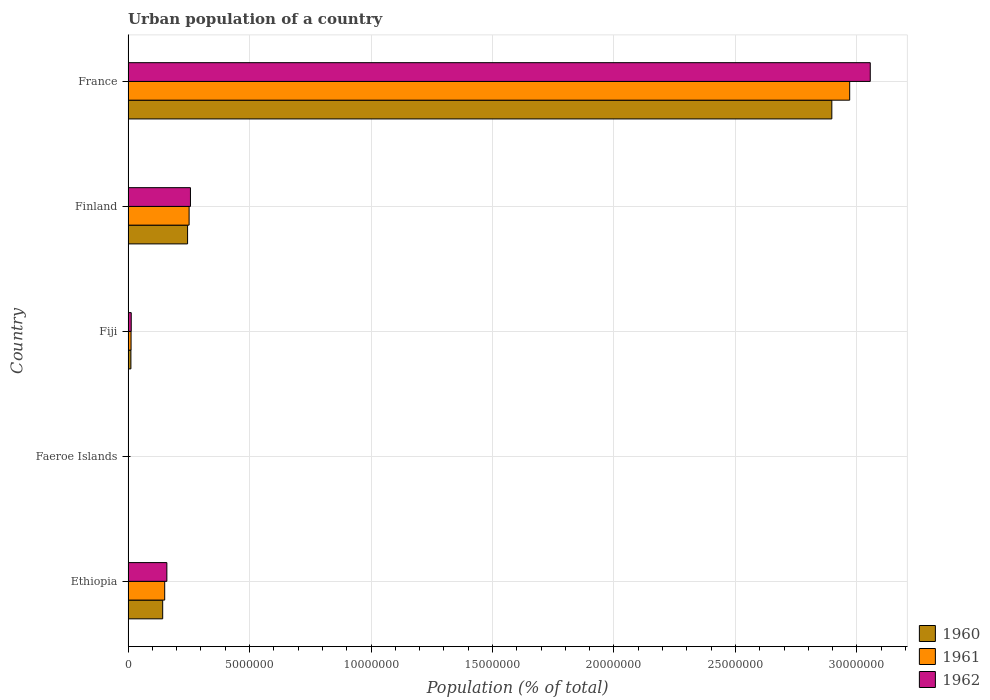How many different coloured bars are there?
Provide a succinct answer. 3. Are the number of bars per tick equal to the number of legend labels?
Give a very brief answer. Yes. How many bars are there on the 1st tick from the top?
Your response must be concise. 3. What is the label of the 5th group of bars from the top?
Make the answer very short. Ethiopia. In how many cases, is the number of bars for a given country not equal to the number of legend labels?
Keep it short and to the point. 0. What is the urban population in 1961 in Finland?
Your answer should be very brief. 2.51e+06. Across all countries, what is the maximum urban population in 1961?
Your answer should be compact. 2.97e+07. Across all countries, what is the minimum urban population in 1960?
Your response must be concise. 7327. In which country was the urban population in 1961 maximum?
Offer a very short reply. France. In which country was the urban population in 1961 minimum?
Ensure brevity in your answer.  Faeroe Islands. What is the total urban population in 1961 in the graph?
Give a very brief answer. 3.39e+07. What is the difference between the urban population in 1962 in Ethiopia and that in Fiji?
Your response must be concise. 1.47e+06. What is the difference between the urban population in 1961 in Faeroe Islands and the urban population in 1960 in Ethiopia?
Your answer should be compact. -1.42e+06. What is the average urban population in 1962 per country?
Give a very brief answer. 6.97e+06. What is the difference between the urban population in 1960 and urban population in 1961 in Faeroe Islands?
Provide a short and direct response. -363. What is the ratio of the urban population in 1961 in Ethiopia to that in Finland?
Provide a short and direct response. 0.6. Is the urban population in 1961 in Faeroe Islands less than that in France?
Your response must be concise. Yes. Is the difference between the urban population in 1960 in Ethiopia and Finland greater than the difference between the urban population in 1961 in Ethiopia and Finland?
Give a very brief answer. No. What is the difference between the highest and the second highest urban population in 1960?
Your answer should be compact. 2.65e+07. What is the difference between the highest and the lowest urban population in 1960?
Keep it short and to the point. 2.90e+07. Is the sum of the urban population in 1960 in Fiji and France greater than the maximum urban population in 1961 across all countries?
Keep it short and to the point. No. What does the 1st bar from the top in France represents?
Your answer should be very brief. 1962. Is it the case that in every country, the sum of the urban population in 1961 and urban population in 1960 is greater than the urban population in 1962?
Your answer should be compact. Yes. How many bars are there?
Offer a very short reply. 15. Where does the legend appear in the graph?
Offer a terse response. Bottom right. What is the title of the graph?
Ensure brevity in your answer.  Urban population of a country. What is the label or title of the X-axis?
Your answer should be very brief. Population (% of total). What is the Population (% of total) in 1960 in Ethiopia?
Give a very brief answer. 1.42e+06. What is the Population (% of total) of 1961 in Ethiopia?
Your answer should be very brief. 1.51e+06. What is the Population (% of total) of 1962 in Ethiopia?
Make the answer very short. 1.60e+06. What is the Population (% of total) of 1960 in Faeroe Islands?
Ensure brevity in your answer.  7327. What is the Population (% of total) in 1961 in Faeroe Islands?
Your answer should be compact. 7690. What is the Population (% of total) of 1962 in Faeroe Islands?
Offer a very short reply. 8072. What is the Population (% of total) in 1960 in Fiji?
Ensure brevity in your answer.  1.17e+05. What is the Population (% of total) in 1961 in Fiji?
Ensure brevity in your answer.  1.23e+05. What is the Population (% of total) of 1962 in Fiji?
Your answer should be compact. 1.30e+05. What is the Population (% of total) of 1960 in Finland?
Provide a short and direct response. 2.45e+06. What is the Population (% of total) in 1961 in Finland?
Provide a short and direct response. 2.51e+06. What is the Population (% of total) in 1962 in Finland?
Offer a terse response. 2.57e+06. What is the Population (% of total) of 1960 in France?
Give a very brief answer. 2.90e+07. What is the Population (% of total) in 1961 in France?
Give a very brief answer. 2.97e+07. What is the Population (% of total) in 1962 in France?
Give a very brief answer. 3.06e+07. Across all countries, what is the maximum Population (% of total) of 1960?
Keep it short and to the point. 2.90e+07. Across all countries, what is the maximum Population (% of total) in 1961?
Give a very brief answer. 2.97e+07. Across all countries, what is the maximum Population (% of total) in 1962?
Offer a terse response. 3.06e+07. Across all countries, what is the minimum Population (% of total) in 1960?
Provide a short and direct response. 7327. Across all countries, what is the minimum Population (% of total) in 1961?
Your answer should be very brief. 7690. Across all countries, what is the minimum Population (% of total) in 1962?
Provide a short and direct response. 8072. What is the total Population (% of total) of 1960 in the graph?
Offer a very short reply. 3.30e+07. What is the total Population (% of total) in 1961 in the graph?
Offer a very short reply. 3.39e+07. What is the total Population (% of total) of 1962 in the graph?
Ensure brevity in your answer.  3.49e+07. What is the difference between the Population (% of total) of 1960 in Ethiopia and that in Faeroe Islands?
Your answer should be compact. 1.42e+06. What is the difference between the Population (% of total) in 1961 in Ethiopia and that in Faeroe Islands?
Give a very brief answer. 1.50e+06. What is the difference between the Population (% of total) of 1962 in Ethiopia and that in Faeroe Islands?
Ensure brevity in your answer.  1.59e+06. What is the difference between the Population (% of total) of 1960 in Ethiopia and that in Fiji?
Your answer should be compact. 1.31e+06. What is the difference between the Population (% of total) in 1961 in Ethiopia and that in Fiji?
Offer a terse response. 1.38e+06. What is the difference between the Population (% of total) in 1962 in Ethiopia and that in Fiji?
Offer a very short reply. 1.47e+06. What is the difference between the Population (% of total) of 1960 in Ethiopia and that in Finland?
Offer a terse response. -1.02e+06. What is the difference between the Population (% of total) in 1961 in Ethiopia and that in Finland?
Offer a very short reply. -1.00e+06. What is the difference between the Population (% of total) in 1962 in Ethiopia and that in Finland?
Provide a succinct answer. -9.71e+05. What is the difference between the Population (% of total) in 1960 in Ethiopia and that in France?
Provide a succinct answer. -2.75e+07. What is the difference between the Population (% of total) of 1961 in Ethiopia and that in France?
Offer a terse response. -2.82e+07. What is the difference between the Population (% of total) in 1962 in Ethiopia and that in France?
Provide a short and direct response. -2.90e+07. What is the difference between the Population (% of total) in 1960 in Faeroe Islands and that in Fiji?
Your answer should be very brief. -1.09e+05. What is the difference between the Population (% of total) in 1961 in Faeroe Islands and that in Fiji?
Your answer should be very brief. -1.15e+05. What is the difference between the Population (% of total) of 1962 in Faeroe Islands and that in Fiji?
Offer a very short reply. -1.22e+05. What is the difference between the Population (% of total) in 1960 in Faeroe Islands and that in Finland?
Offer a very short reply. -2.44e+06. What is the difference between the Population (% of total) in 1961 in Faeroe Islands and that in Finland?
Your response must be concise. -2.50e+06. What is the difference between the Population (% of total) in 1962 in Faeroe Islands and that in Finland?
Offer a terse response. -2.56e+06. What is the difference between the Population (% of total) of 1960 in Faeroe Islands and that in France?
Make the answer very short. -2.90e+07. What is the difference between the Population (% of total) in 1961 in Faeroe Islands and that in France?
Your answer should be very brief. -2.97e+07. What is the difference between the Population (% of total) in 1962 in Faeroe Islands and that in France?
Your answer should be compact. -3.05e+07. What is the difference between the Population (% of total) in 1960 in Fiji and that in Finland?
Your response must be concise. -2.33e+06. What is the difference between the Population (% of total) in 1961 in Fiji and that in Finland?
Your answer should be very brief. -2.39e+06. What is the difference between the Population (% of total) of 1962 in Fiji and that in Finland?
Offer a very short reply. -2.44e+06. What is the difference between the Population (% of total) of 1960 in Fiji and that in France?
Your answer should be compact. -2.89e+07. What is the difference between the Population (% of total) in 1961 in Fiji and that in France?
Your response must be concise. -2.96e+07. What is the difference between the Population (% of total) of 1962 in Fiji and that in France?
Provide a short and direct response. -3.04e+07. What is the difference between the Population (% of total) in 1960 in Finland and that in France?
Offer a terse response. -2.65e+07. What is the difference between the Population (% of total) in 1961 in Finland and that in France?
Make the answer very short. -2.72e+07. What is the difference between the Population (% of total) in 1962 in Finland and that in France?
Keep it short and to the point. -2.80e+07. What is the difference between the Population (% of total) of 1960 in Ethiopia and the Population (% of total) of 1961 in Faeroe Islands?
Your response must be concise. 1.42e+06. What is the difference between the Population (% of total) of 1960 in Ethiopia and the Population (% of total) of 1962 in Faeroe Islands?
Offer a very short reply. 1.42e+06. What is the difference between the Population (% of total) of 1961 in Ethiopia and the Population (% of total) of 1962 in Faeroe Islands?
Provide a succinct answer. 1.50e+06. What is the difference between the Population (% of total) of 1960 in Ethiopia and the Population (% of total) of 1961 in Fiji?
Keep it short and to the point. 1.30e+06. What is the difference between the Population (% of total) in 1960 in Ethiopia and the Population (% of total) in 1962 in Fiji?
Ensure brevity in your answer.  1.30e+06. What is the difference between the Population (% of total) of 1961 in Ethiopia and the Population (% of total) of 1962 in Fiji?
Offer a terse response. 1.38e+06. What is the difference between the Population (% of total) in 1960 in Ethiopia and the Population (% of total) in 1961 in Finland?
Your answer should be compact. -1.09e+06. What is the difference between the Population (% of total) of 1960 in Ethiopia and the Population (% of total) of 1962 in Finland?
Make the answer very short. -1.14e+06. What is the difference between the Population (% of total) of 1961 in Ethiopia and the Population (% of total) of 1962 in Finland?
Offer a very short reply. -1.06e+06. What is the difference between the Population (% of total) in 1960 in Ethiopia and the Population (% of total) in 1961 in France?
Keep it short and to the point. -2.83e+07. What is the difference between the Population (% of total) of 1960 in Ethiopia and the Population (% of total) of 1962 in France?
Provide a short and direct response. -2.91e+07. What is the difference between the Population (% of total) of 1961 in Ethiopia and the Population (% of total) of 1962 in France?
Your answer should be compact. -2.90e+07. What is the difference between the Population (% of total) of 1960 in Faeroe Islands and the Population (% of total) of 1961 in Fiji?
Provide a short and direct response. -1.16e+05. What is the difference between the Population (% of total) in 1960 in Faeroe Islands and the Population (% of total) in 1962 in Fiji?
Make the answer very short. -1.23e+05. What is the difference between the Population (% of total) in 1961 in Faeroe Islands and the Population (% of total) in 1962 in Fiji?
Provide a succinct answer. -1.22e+05. What is the difference between the Population (% of total) in 1960 in Faeroe Islands and the Population (% of total) in 1961 in Finland?
Your answer should be compact. -2.51e+06. What is the difference between the Population (% of total) in 1960 in Faeroe Islands and the Population (% of total) in 1962 in Finland?
Give a very brief answer. -2.56e+06. What is the difference between the Population (% of total) of 1961 in Faeroe Islands and the Population (% of total) of 1962 in Finland?
Provide a short and direct response. -2.56e+06. What is the difference between the Population (% of total) in 1960 in Faeroe Islands and the Population (% of total) in 1961 in France?
Offer a very short reply. -2.97e+07. What is the difference between the Population (% of total) of 1960 in Faeroe Islands and the Population (% of total) of 1962 in France?
Make the answer very short. -3.05e+07. What is the difference between the Population (% of total) of 1961 in Faeroe Islands and the Population (% of total) of 1962 in France?
Provide a succinct answer. -3.05e+07. What is the difference between the Population (% of total) in 1960 in Fiji and the Population (% of total) in 1961 in Finland?
Your answer should be very brief. -2.40e+06. What is the difference between the Population (% of total) in 1960 in Fiji and the Population (% of total) in 1962 in Finland?
Provide a short and direct response. -2.45e+06. What is the difference between the Population (% of total) of 1961 in Fiji and the Population (% of total) of 1962 in Finland?
Make the answer very short. -2.44e+06. What is the difference between the Population (% of total) in 1960 in Fiji and the Population (% of total) in 1961 in France?
Give a very brief answer. -2.96e+07. What is the difference between the Population (% of total) in 1960 in Fiji and the Population (% of total) in 1962 in France?
Provide a short and direct response. -3.04e+07. What is the difference between the Population (% of total) in 1961 in Fiji and the Population (% of total) in 1962 in France?
Offer a terse response. -3.04e+07. What is the difference between the Population (% of total) of 1960 in Finland and the Population (% of total) of 1961 in France?
Your answer should be compact. -2.73e+07. What is the difference between the Population (% of total) of 1960 in Finland and the Population (% of total) of 1962 in France?
Make the answer very short. -2.81e+07. What is the difference between the Population (% of total) in 1961 in Finland and the Population (% of total) in 1962 in France?
Offer a terse response. -2.80e+07. What is the average Population (% of total) of 1960 per country?
Give a very brief answer. 6.59e+06. What is the average Population (% of total) in 1961 per country?
Keep it short and to the point. 6.77e+06. What is the average Population (% of total) in 1962 per country?
Provide a succinct answer. 6.97e+06. What is the difference between the Population (% of total) of 1960 and Population (% of total) of 1961 in Ethiopia?
Your response must be concise. -8.26e+04. What is the difference between the Population (% of total) of 1960 and Population (% of total) of 1962 in Ethiopia?
Provide a succinct answer. -1.71e+05. What is the difference between the Population (% of total) in 1961 and Population (% of total) in 1962 in Ethiopia?
Ensure brevity in your answer.  -8.86e+04. What is the difference between the Population (% of total) in 1960 and Population (% of total) in 1961 in Faeroe Islands?
Ensure brevity in your answer.  -363. What is the difference between the Population (% of total) of 1960 and Population (% of total) of 1962 in Faeroe Islands?
Your answer should be compact. -745. What is the difference between the Population (% of total) of 1961 and Population (% of total) of 1962 in Faeroe Islands?
Your answer should be compact. -382. What is the difference between the Population (% of total) in 1960 and Population (% of total) in 1961 in Fiji?
Offer a terse response. -6395. What is the difference between the Population (% of total) in 1960 and Population (% of total) in 1962 in Fiji?
Provide a succinct answer. -1.32e+04. What is the difference between the Population (% of total) of 1961 and Population (% of total) of 1962 in Fiji?
Your response must be concise. -6787. What is the difference between the Population (% of total) of 1960 and Population (% of total) of 1961 in Finland?
Offer a terse response. -6.33e+04. What is the difference between the Population (% of total) in 1960 and Population (% of total) in 1962 in Finland?
Keep it short and to the point. -1.18e+05. What is the difference between the Population (% of total) of 1961 and Population (% of total) of 1962 in Finland?
Your response must be concise. -5.49e+04. What is the difference between the Population (% of total) in 1960 and Population (% of total) in 1961 in France?
Your response must be concise. -7.35e+05. What is the difference between the Population (% of total) of 1960 and Population (% of total) of 1962 in France?
Your answer should be compact. -1.58e+06. What is the difference between the Population (% of total) in 1961 and Population (% of total) in 1962 in France?
Your response must be concise. -8.47e+05. What is the ratio of the Population (% of total) in 1960 in Ethiopia to that in Faeroe Islands?
Your answer should be very brief. 194.48. What is the ratio of the Population (% of total) of 1961 in Ethiopia to that in Faeroe Islands?
Your response must be concise. 196.05. What is the ratio of the Population (% of total) of 1962 in Ethiopia to that in Faeroe Islands?
Provide a succinct answer. 197.75. What is the ratio of the Population (% of total) in 1960 in Ethiopia to that in Fiji?
Provide a succinct answer. 12.2. What is the ratio of the Population (% of total) of 1961 in Ethiopia to that in Fiji?
Offer a very short reply. 12.24. What is the ratio of the Population (% of total) of 1962 in Ethiopia to that in Fiji?
Keep it short and to the point. 12.28. What is the ratio of the Population (% of total) in 1960 in Ethiopia to that in Finland?
Provide a short and direct response. 0.58. What is the ratio of the Population (% of total) of 1961 in Ethiopia to that in Finland?
Give a very brief answer. 0.6. What is the ratio of the Population (% of total) of 1962 in Ethiopia to that in Finland?
Provide a short and direct response. 0.62. What is the ratio of the Population (% of total) of 1960 in Ethiopia to that in France?
Your answer should be very brief. 0.05. What is the ratio of the Population (% of total) in 1961 in Ethiopia to that in France?
Provide a short and direct response. 0.05. What is the ratio of the Population (% of total) of 1962 in Ethiopia to that in France?
Provide a succinct answer. 0.05. What is the ratio of the Population (% of total) in 1960 in Faeroe Islands to that in Fiji?
Offer a terse response. 0.06. What is the ratio of the Population (% of total) in 1961 in Faeroe Islands to that in Fiji?
Provide a succinct answer. 0.06. What is the ratio of the Population (% of total) of 1962 in Faeroe Islands to that in Fiji?
Your answer should be very brief. 0.06. What is the ratio of the Population (% of total) in 1960 in Faeroe Islands to that in Finland?
Provide a succinct answer. 0. What is the ratio of the Population (% of total) in 1961 in Faeroe Islands to that in Finland?
Your answer should be very brief. 0. What is the ratio of the Population (% of total) in 1962 in Faeroe Islands to that in Finland?
Keep it short and to the point. 0. What is the ratio of the Population (% of total) of 1960 in Faeroe Islands to that in France?
Offer a very short reply. 0. What is the ratio of the Population (% of total) in 1961 in Faeroe Islands to that in France?
Give a very brief answer. 0. What is the ratio of the Population (% of total) in 1962 in Faeroe Islands to that in France?
Ensure brevity in your answer.  0. What is the ratio of the Population (% of total) in 1960 in Fiji to that in Finland?
Your answer should be compact. 0.05. What is the ratio of the Population (% of total) of 1961 in Fiji to that in Finland?
Provide a short and direct response. 0.05. What is the ratio of the Population (% of total) in 1962 in Fiji to that in Finland?
Provide a short and direct response. 0.05. What is the ratio of the Population (% of total) in 1960 in Fiji to that in France?
Offer a very short reply. 0. What is the ratio of the Population (% of total) in 1961 in Fiji to that in France?
Offer a terse response. 0. What is the ratio of the Population (% of total) of 1962 in Fiji to that in France?
Ensure brevity in your answer.  0. What is the ratio of the Population (% of total) of 1960 in Finland to that in France?
Ensure brevity in your answer.  0.08. What is the ratio of the Population (% of total) of 1961 in Finland to that in France?
Provide a succinct answer. 0.08. What is the ratio of the Population (% of total) of 1962 in Finland to that in France?
Offer a very short reply. 0.08. What is the difference between the highest and the second highest Population (% of total) in 1960?
Make the answer very short. 2.65e+07. What is the difference between the highest and the second highest Population (% of total) of 1961?
Make the answer very short. 2.72e+07. What is the difference between the highest and the second highest Population (% of total) of 1962?
Keep it short and to the point. 2.80e+07. What is the difference between the highest and the lowest Population (% of total) in 1960?
Your response must be concise. 2.90e+07. What is the difference between the highest and the lowest Population (% of total) of 1961?
Keep it short and to the point. 2.97e+07. What is the difference between the highest and the lowest Population (% of total) of 1962?
Your response must be concise. 3.05e+07. 